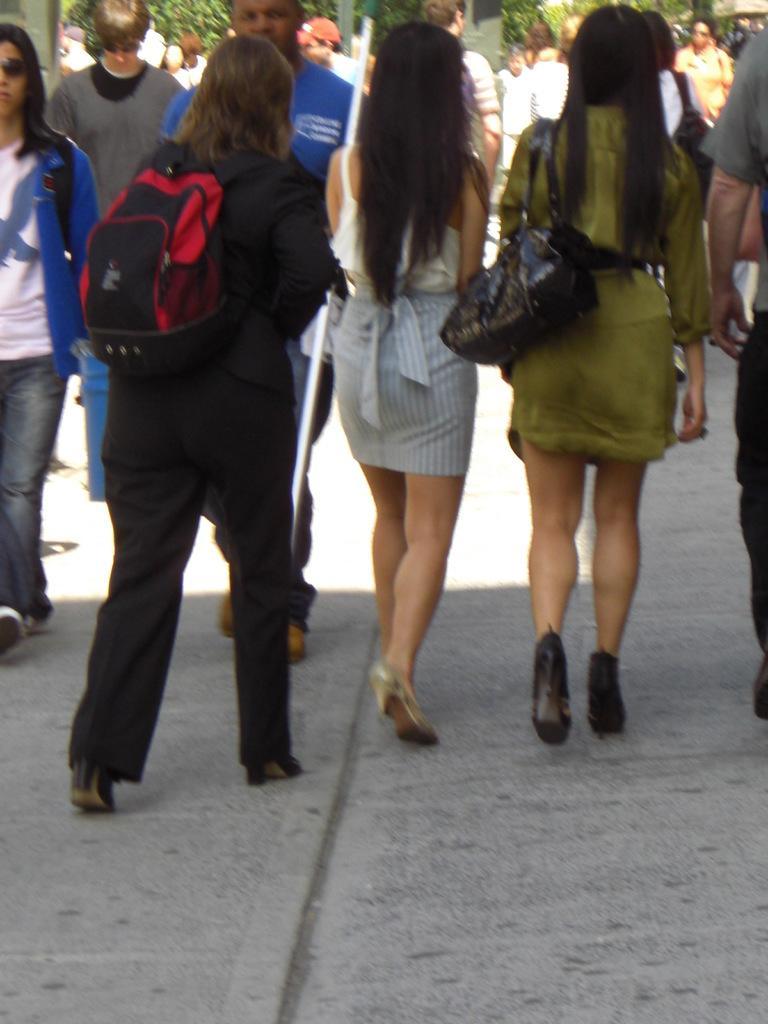Describe this image in one or two sentences. In this picture we can see a few people walking on the path. We can see two women wearing bags. There are a few plants visible in the background. 